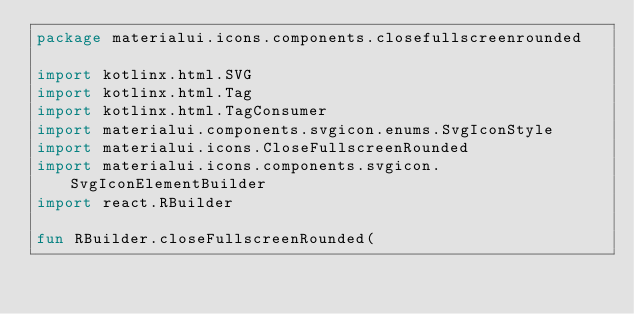Convert code to text. <code><loc_0><loc_0><loc_500><loc_500><_Kotlin_>package materialui.icons.components.closefullscreenrounded

import kotlinx.html.SVG
import kotlinx.html.Tag
import kotlinx.html.TagConsumer
import materialui.components.svgicon.enums.SvgIconStyle
import materialui.icons.CloseFullscreenRounded
import materialui.icons.components.svgicon.SvgIconElementBuilder
import react.RBuilder

fun RBuilder.closeFullscreenRounded(</code> 